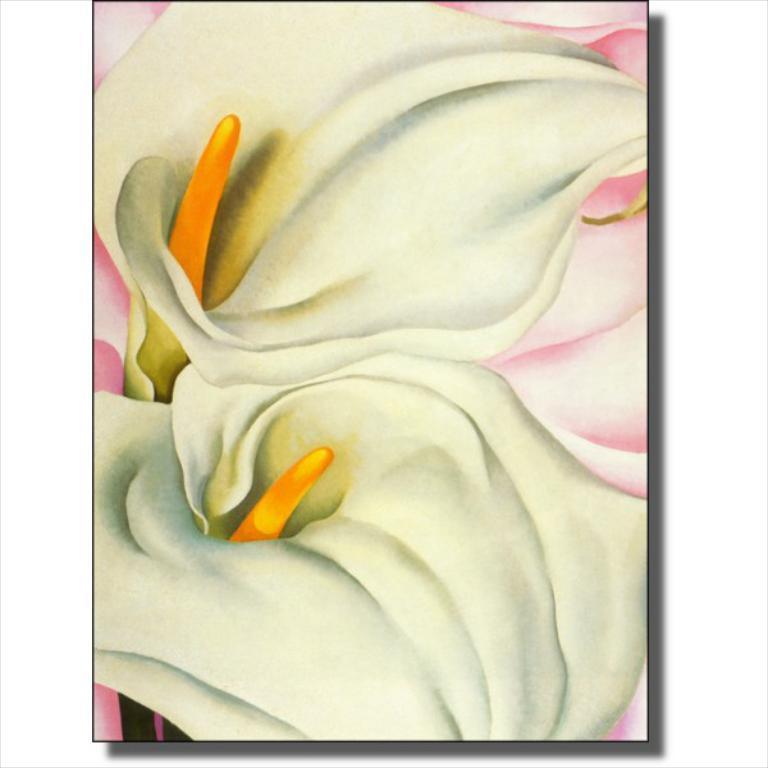Can you describe this image briefly? This is an edited poster where we can see two white flowers and orange stigma. The background is in pink color. 